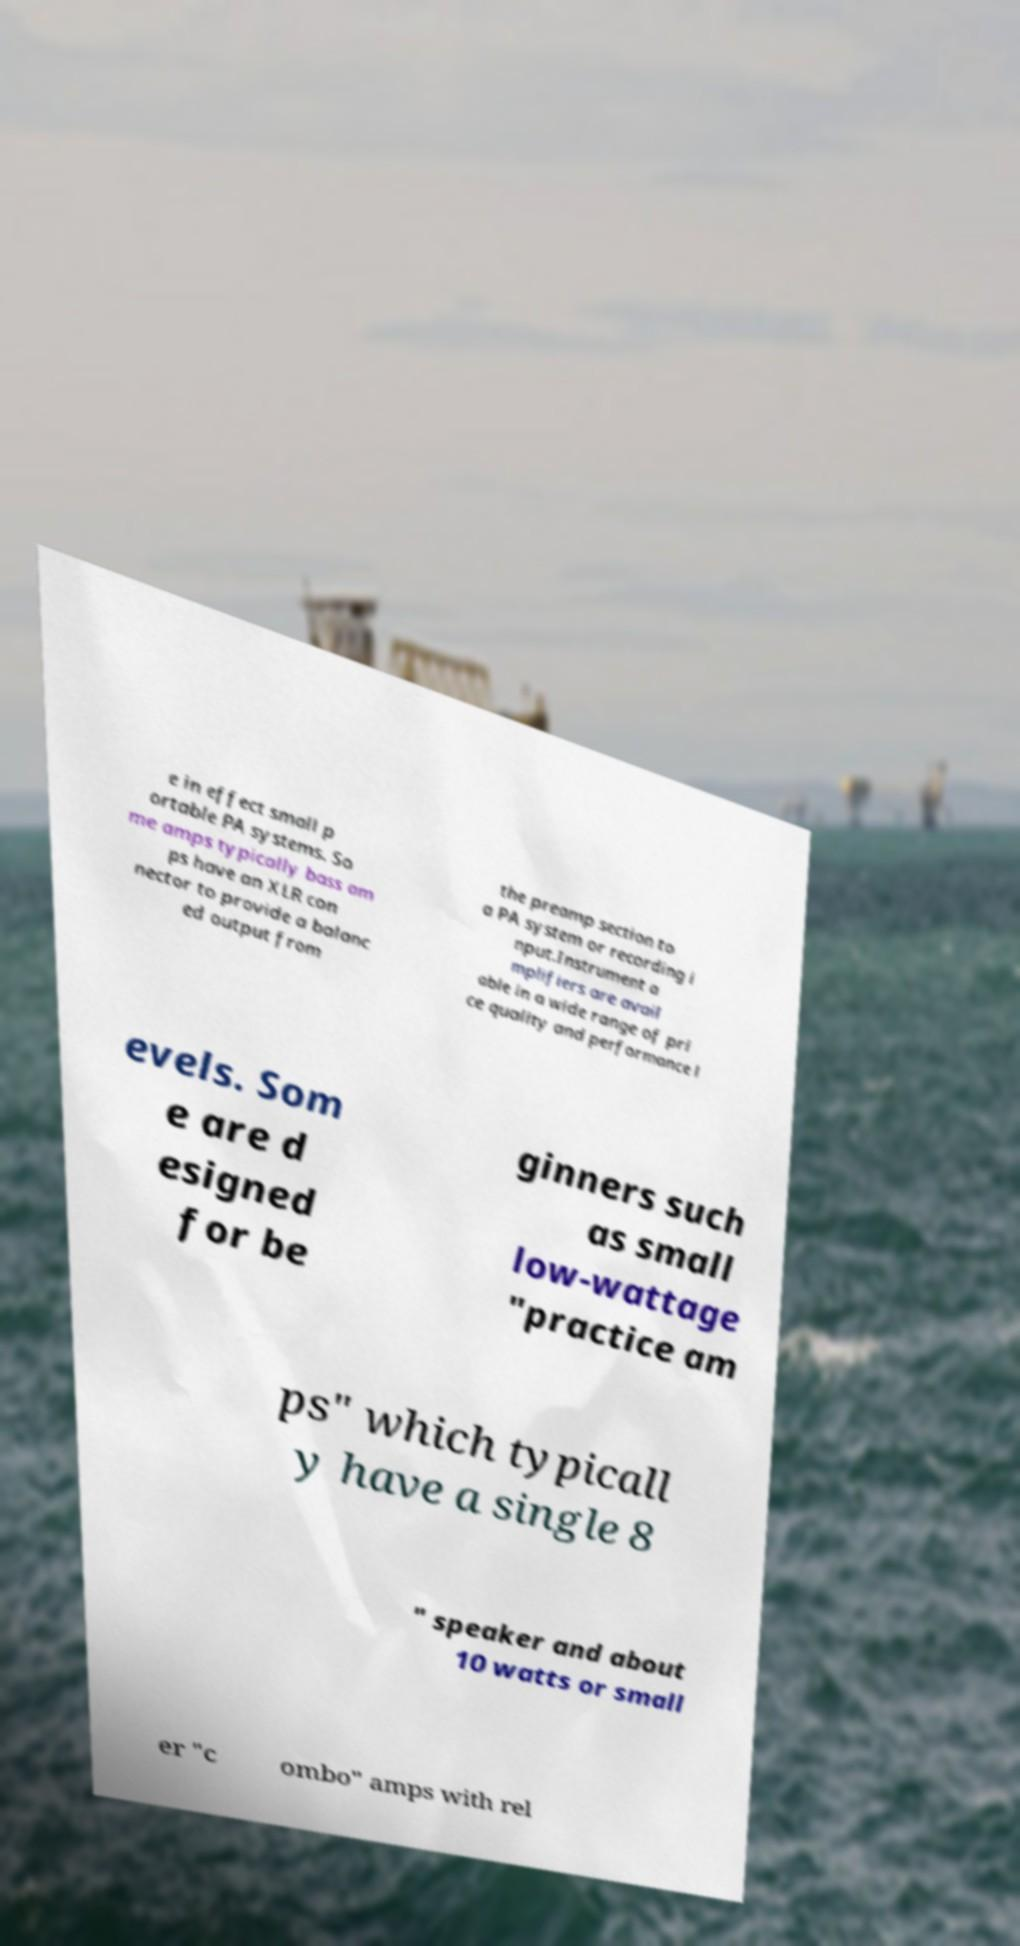Please identify and transcribe the text found in this image. e in effect small p ortable PA systems. So me amps typically bass am ps have an XLR con nector to provide a balanc ed output from the preamp section to a PA system or recording i nput.Instrument a mplifiers are avail able in a wide range of pri ce quality and performance l evels. Som e are d esigned for be ginners such as small low-wattage "practice am ps" which typicall y have a single 8 " speaker and about 10 watts or small er "c ombo" amps with rel 